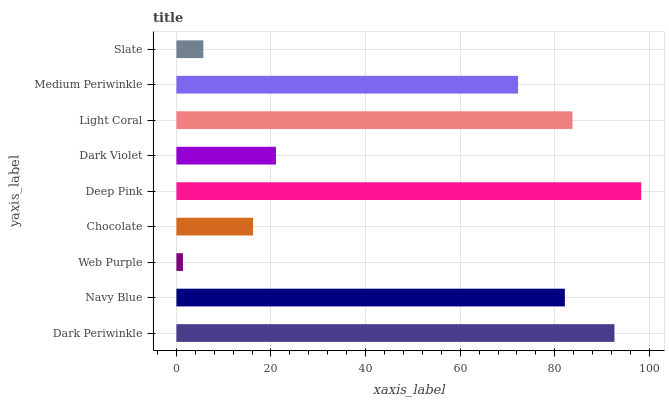Is Web Purple the minimum?
Answer yes or no. Yes. Is Deep Pink the maximum?
Answer yes or no. Yes. Is Navy Blue the minimum?
Answer yes or no. No. Is Navy Blue the maximum?
Answer yes or no. No. Is Dark Periwinkle greater than Navy Blue?
Answer yes or no. Yes. Is Navy Blue less than Dark Periwinkle?
Answer yes or no. Yes. Is Navy Blue greater than Dark Periwinkle?
Answer yes or no. No. Is Dark Periwinkle less than Navy Blue?
Answer yes or no. No. Is Medium Periwinkle the high median?
Answer yes or no. Yes. Is Medium Periwinkle the low median?
Answer yes or no. Yes. Is Navy Blue the high median?
Answer yes or no. No. Is Slate the low median?
Answer yes or no. No. 